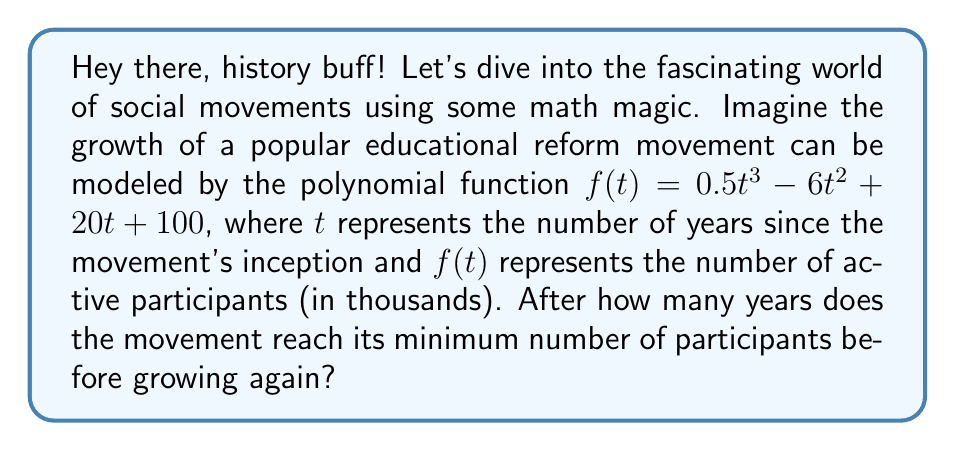Show me your answer to this math problem. Alright, let's break this down step-by-step:

1) To find the minimum point, we need to find where the derivative of the function equals zero. This will give us the critical points.

2) The derivative of $f(t)$ is:
   $f'(t) = 1.5t^2 - 12t + 20$

3) Set $f'(t) = 0$ and solve:
   $1.5t^2 - 12t + 20 = 0$

4) This is a quadratic equation. We can solve it using the quadratic formula:
   $t = \frac{-b \pm \sqrt{b^2 - 4ac}}{2a}$

   Where $a = 1.5$, $b = -12$, and $c = 20$

5) Plugging in these values:
   $t = \frac{12 \pm \sqrt{144 - 120}}{3} = \frac{12 \pm \sqrt{24}}{3} = \frac{12 \pm 2\sqrt{6}}{3}$

6) This gives us two solutions:
   $t_1 = \frac{12 + 2\sqrt{6}}{3} \approx 5.63$ years
   $t_2 = \frac{12 - 2\sqrt{6}}{3} \approx 2.37$ years

7) The second critical point ($t_2$) is the minimum, as the function is decreasing before this point and increasing after it.

8) Since we're asked for the number of years, we round up to the nearest whole year.
Answer: 3 years 